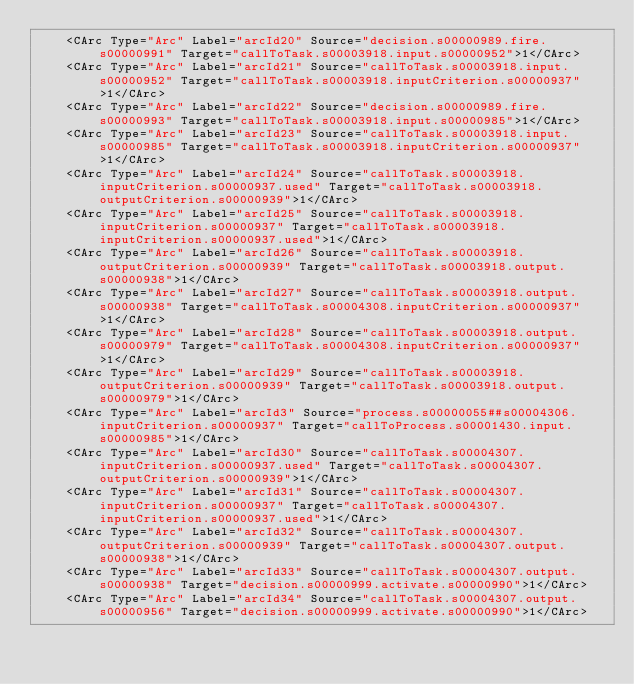Convert code to text. <code><loc_0><loc_0><loc_500><loc_500><_XML_>    <CArc Type="Arc" Label="arcId20" Source="decision.s00000989.fire.s00000991" Target="callToTask.s00003918.input.s00000952">1</CArc>
    <CArc Type="Arc" Label="arcId21" Source="callToTask.s00003918.input.s00000952" Target="callToTask.s00003918.inputCriterion.s00000937">1</CArc>
    <CArc Type="Arc" Label="arcId22" Source="decision.s00000989.fire.s00000993" Target="callToTask.s00003918.input.s00000985">1</CArc>
    <CArc Type="Arc" Label="arcId23" Source="callToTask.s00003918.input.s00000985" Target="callToTask.s00003918.inputCriterion.s00000937">1</CArc>
    <CArc Type="Arc" Label="arcId24" Source="callToTask.s00003918.inputCriterion.s00000937.used" Target="callToTask.s00003918.outputCriterion.s00000939">1</CArc>
    <CArc Type="Arc" Label="arcId25" Source="callToTask.s00003918.inputCriterion.s00000937" Target="callToTask.s00003918.inputCriterion.s00000937.used">1</CArc>
    <CArc Type="Arc" Label="arcId26" Source="callToTask.s00003918.outputCriterion.s00000939" Target="callToTask.s00003918.output.s00000938">1</CArc>
    <CArc Type="Arc" Label="arcId27" Source="callToTask.s00003918.output.s00000938" Target="callToTask.s00004308.inputCriterion.s00000937">1</CArc>
    <CArc Type="Arc" Label="arcId28" Source="callToTask.s00003918.output.s00000979" Target="callToTask.s00004308.inputCriterion.s00000937">1</CArc>
    <CArc Type="Arc" Label="arcId29" Source="callToTask.s00003918.outputCriterion.s00000939" Target="callToTask.s00003918.output.s00000979">1</CArc>
    <CArc Type="Arc" Label="arcId3" Source="process.s00000055##s00004306.inputCriterion.s00000937" Target="callToProcess.s00001430.input.s00000985">1</CArc>
    <CArc Type="Arc" Label="arcId30" Source="callToTask.s00004307.inputCriterion.s00000937.used" Target="callToTask.s00004307.outputCriterion.s00000939">1</CArc>
    <CArc Type="Arc" Label="arcId31" Source="callToTask.s00004307.inputCriterion.s00000937" Target="callToTask.s00004307.inputCriterion.s00000937.used">1</CArc>
    <CArc Type="Arc" Label="arcId32" Source="callToTask.s00004307.outputCriterion.s00000939" Target="callToTask.s00004307.output.s00000938">1</CArc>
    <CArc Type="Arc" Label="arcId33" Source="callToTask.s00004307.output.s00000938" Target="decision.s00000999.activate.s00000990">1</CArc>
    <CArc Type="Arc" Label="arcId34" Source="callToTask.s00004307.output.s00000956" Target="decision.s00000999.activate.s00000990">1</CArc></code> 